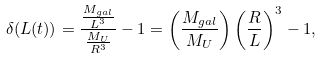<formula> <loc_0><loc_0><loc_500><loc_500>\delta ( L ( t ) ) = \frac { \frac { M _ { g a l } } { L ^ { 3 } } } { \frac { M _ { U } } { R ^ { 3 } } } - 1 = \left ( \frac { M _ { g a l } } { M _ { U } } \right ) \left ( \frac { R } { L } \right ) ^ { 3 } - 1 ,</formula> 